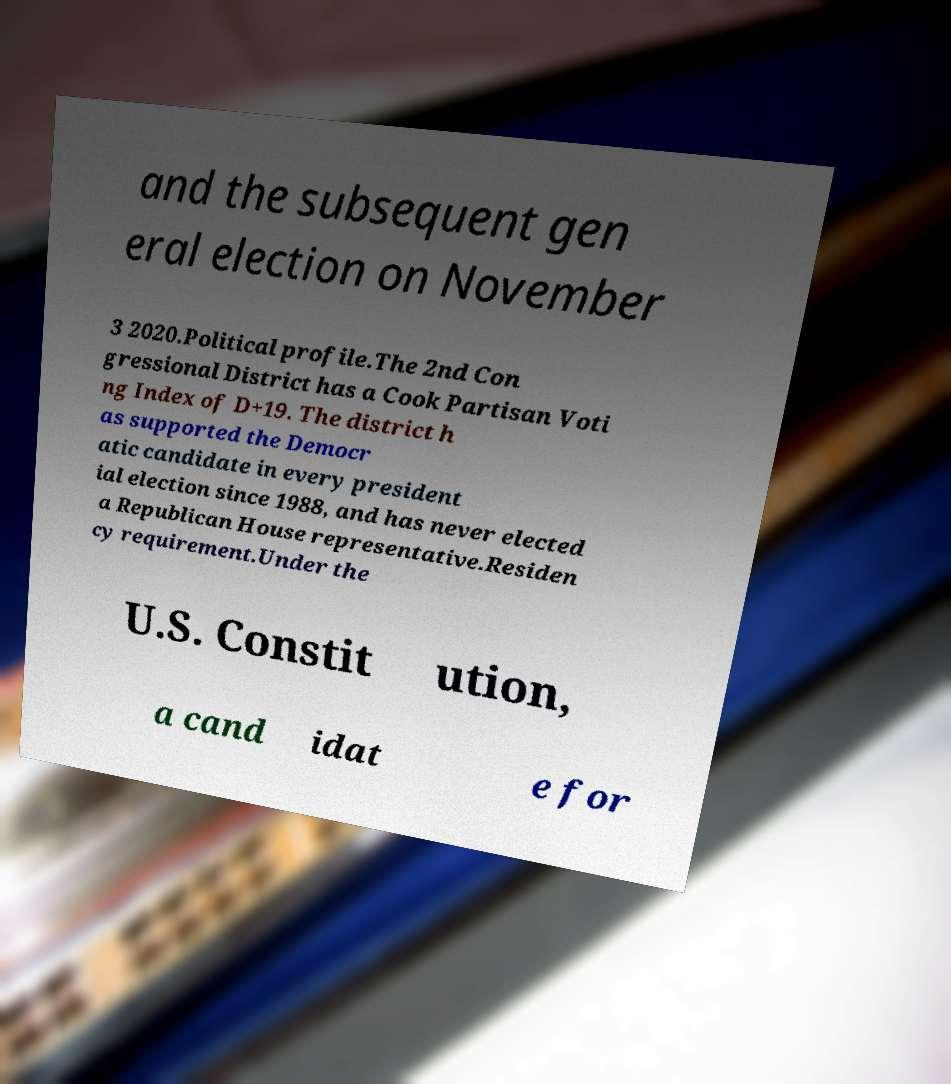Please identify and transcribe the text found in this image. and the subsequent gen eral election on November 3 2020.Political profile.The 2nd Con gressional District has a Cook Partisan Voti ng Index of D+19. The district h as supported the Democr atic candidate in every president ial election since 1988, and has never elected a Republican House representative.Residen cy requirement.Under the U.S. Constit ution, a cand idat e for 